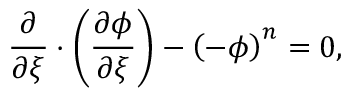<formula> <loc_0><loc_0><loc_500><loc_500>\frac { \partial } { \partial \xi } \cdot \left ( \frac { \partial \phi } { \partial \xi } \right ) - \left ( - \phi \right ) ^ { n } = 0 ,</formula> 